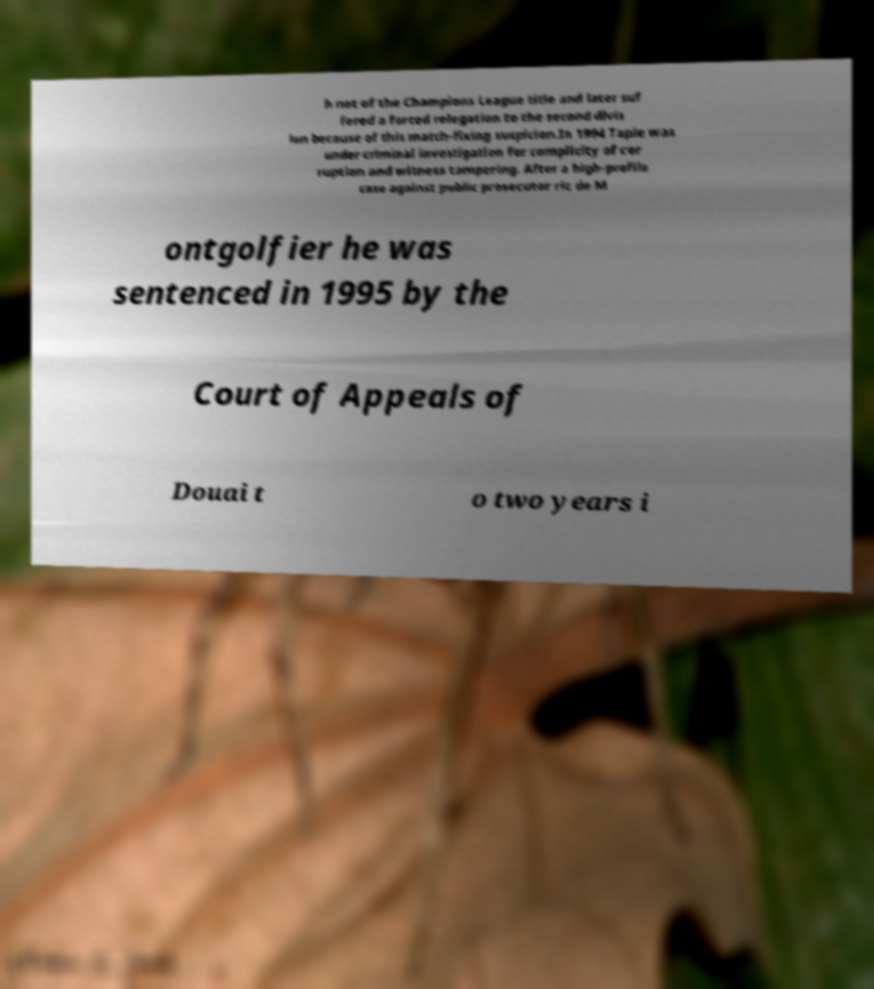I need the written content from this picture converted into text. Can you do that? h not of the Champions League title and later suf fered a forced relegation to the second divis ion because of this match-fixing suspicion.In 1994 Tapie was under criminal investigation for complicity of cor ruption and witness tampering. After a high-profile case against public prosecutor ric de M ontgolfier he was sentenced in 1995 by the Court of Appeals of Douai t o two years i 